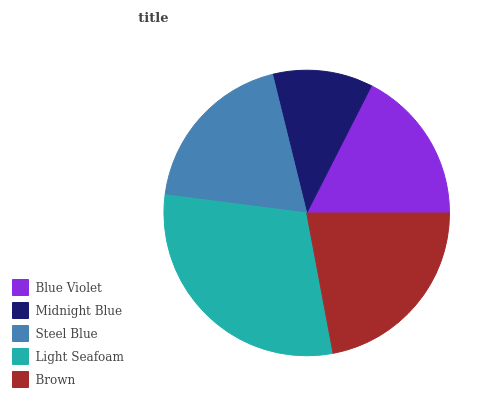Is Midnight Blue the minimum?
Answer yes or no. Yes. Is Light Seafoam the maximum?
Answer yes or no. Yes. Is Steel Blue the minimum?
Answer yes or no. No. Is Steel Blue the maximum?
Answer yes or no. No. Is Steel Blue greater than Midnight Blue?
Answer yes or no. Yes. Is Midnight Blue less than Steel Blue?
Answer yes or no. Yes. Is Midnight Blue greater than Steel Blue?
Answer yes or no. No. Is Steel Blue less than Midnight Blue?
Answer yes or no. No. Is Steel Blue the high median?
Answer yes or no. Yes. Is Steel Blue the low median?
Answer yes or no. Yes. Is Midnight Blue the high median?
Answer yes or no. No. Is Blue Violet the low median?
Answer yes or no. No. 